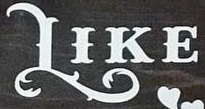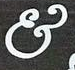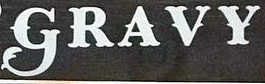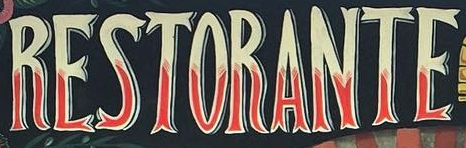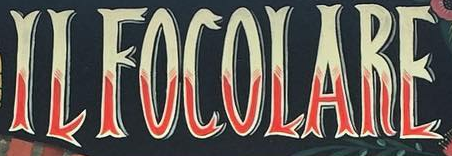What text is displayed in these images sequentially, separated by a semicolon? LIKE; &; GRAVY; RESTORANTE; ILFOCOLARE 